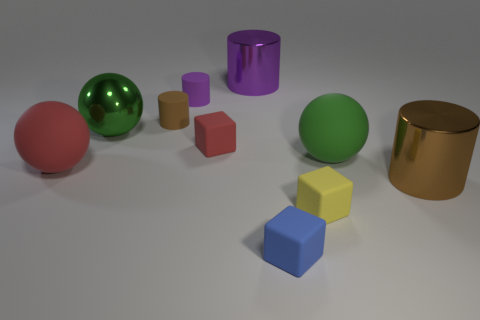Does the rubber sphere that is on the right side of the blue matte object have the same color as the metal ball?
Your answer should be very brief. Yes. There is a thing that is the same color as the metallic sphere; what shape is it?
Your response must be concise. Sphere. What is the size of the other ball that is the same color as the metallic ball?
Your answer should be compact. Large. The brown object behind the big brown metallic thing has what shape?
Offer a terse response. Cylinder. Are there fewer tiny matte blocks than big green metallic objects?
Give a very brief answer. No. Are there any big red objects that are behind the tiny rubber block behind the big cylinder that is in front of the small brown rubber thing?
Provide a short and direct response. No. How many rubber things are red blocks or small yellow objects?
Give a very brief answer. 2. There is a big purple metal cylinder; what number of big brown metal cylinders are behind it?
Provide a succinct answer. 0. What number of objects are both on the right side of the large red ball and in front of the purple shiny thing?
Keep it short and to the point. 8. What is the shape of the big green object that is the same material as the yellow block?
Provide a short and direct response. Sphere. 